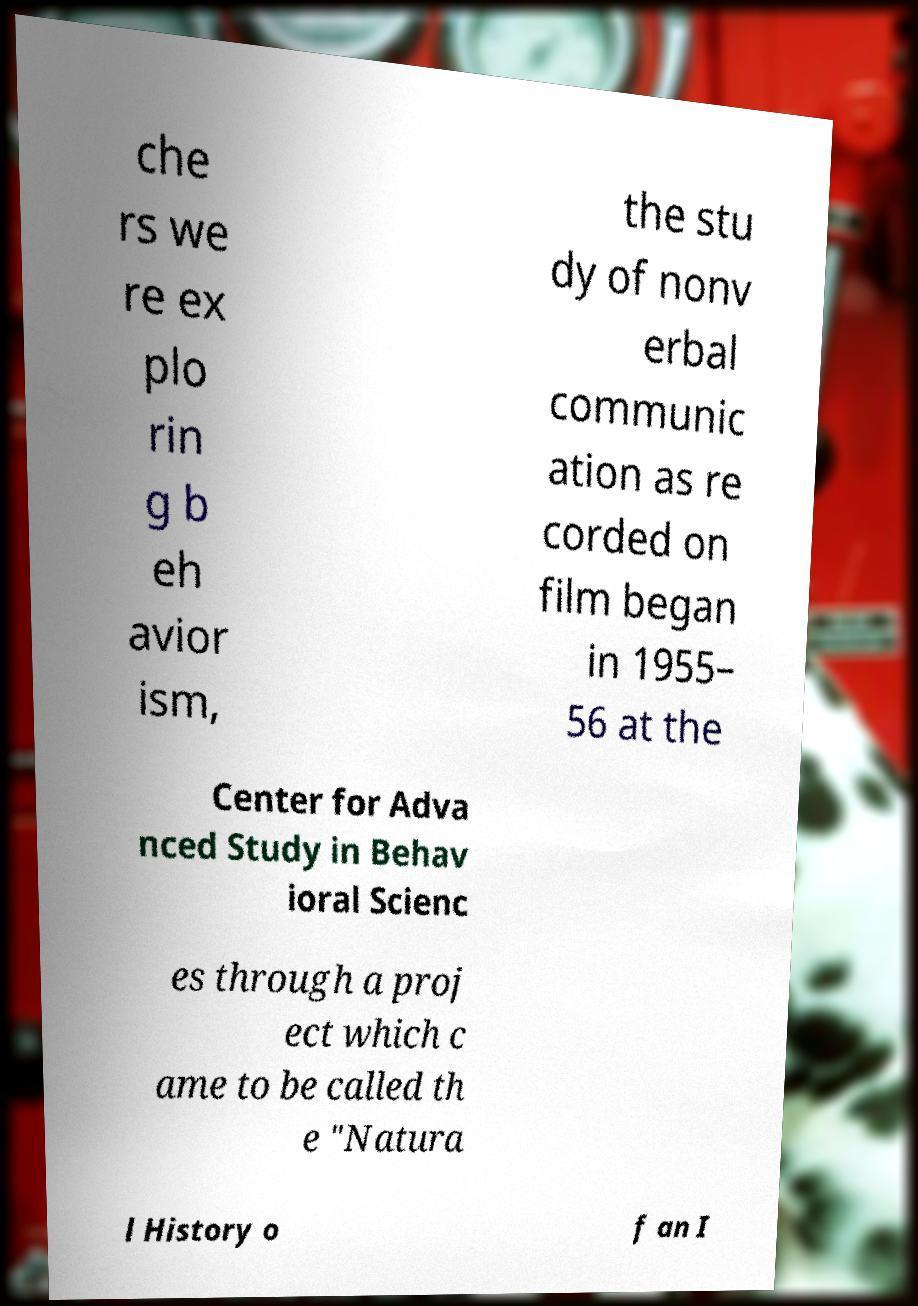I need the written content from this picture converted into text. Can you do that? che rs we re ex plo rin g b eh avior ism, the stu dy of nonv erbal communic ation as re corded on film began in 1955– 56 at the Center for Adva nced Study in Behav ioral Scienc es through a proj ect which c ame to be called th e "Natura l History o f an I 